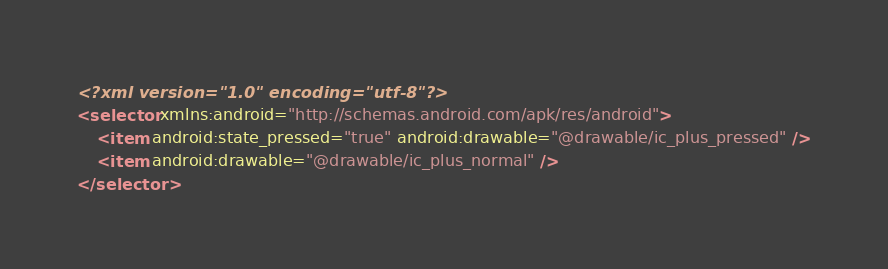<code> <loc_0><loc_0><loc_500><loc_500><_XML_><?xml version="1.0" encoding="utf-8"?>
<selector xmlns:android="http://schemas.android.com/apk/res/android">
    <item android:state_pressed="true" android:drawable="@drawable/ic_plus_pressed" />
    <item android:drawable="@drawable/ic_plus_normal" />
</selector></code> 